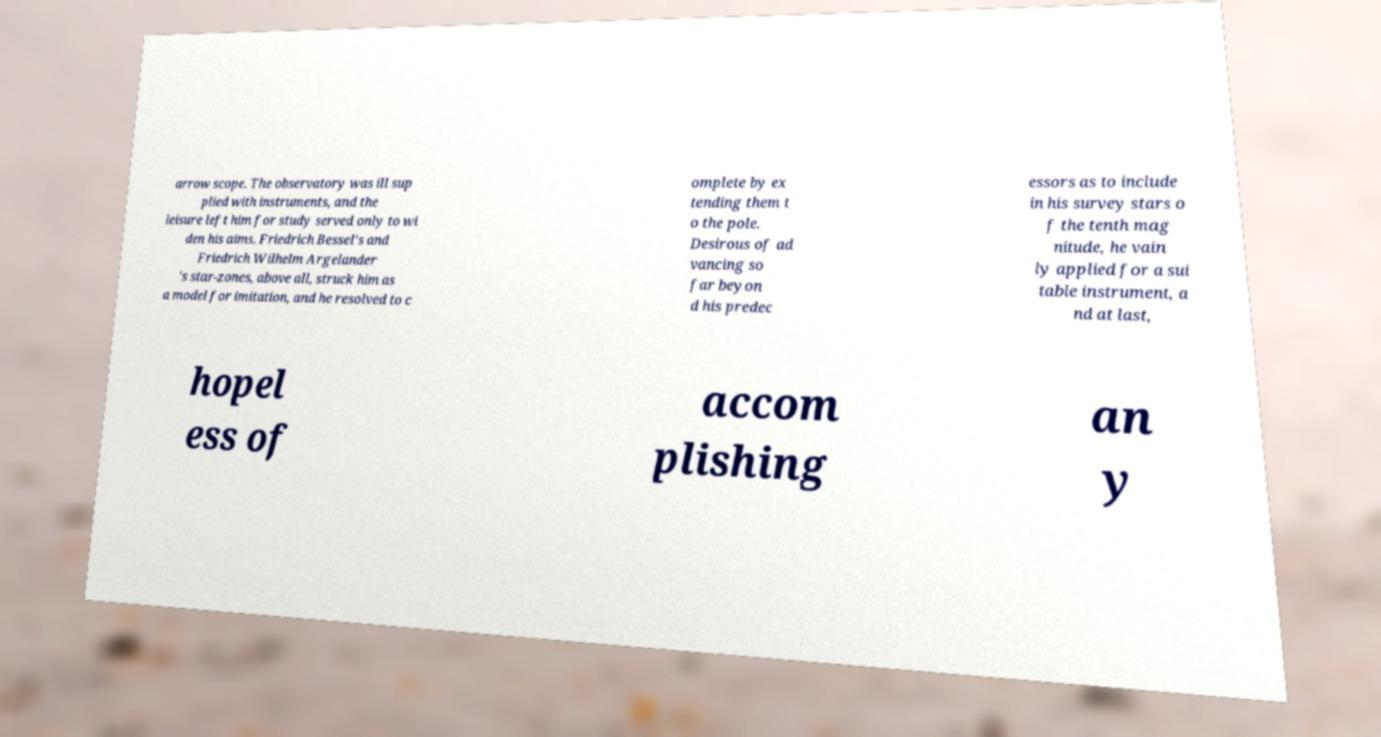Can you read and provide the text displayed in the image?This photo seems to have some interesting text. Can you extract and type it out for me? arrow scope. The observatory was ill sup plied with instruments, and the leisure left him for study served only to wi den his aims. Friedrich Bessel's and Friedrich Wilhelm Argelander 's star-zones, above all, struck him as a model for imitation, and he resolved to c omplete by ex tending them t o the pole. Desirous of ad vancing so far beyon d his predec essors as to include in his survey stars o f the tenth mag nitude, he vain ly applied for a sui table instrument, a nd at last, hopel ess of accom plishing an y 